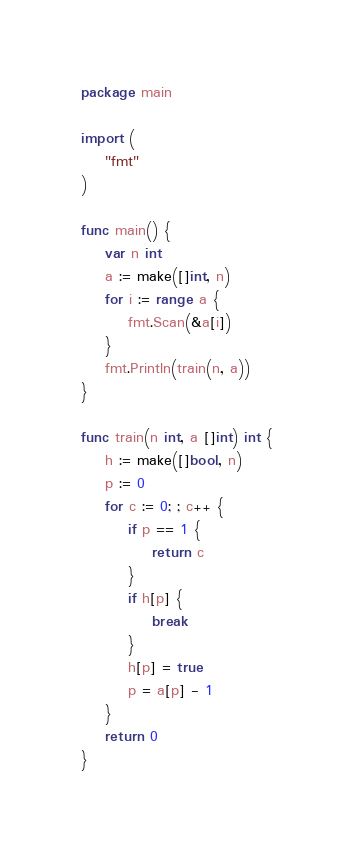Convert code to text. <code><loc_0><loc_0><loc_500><loc_500><_Go_>package main

import (
	"fmt"
)

func main() {
	var n int
	a := make([]int, n)
	for i := range a {
		fmt.Scan(&a[i])
	}
	fmt.Println(train(n, a))
}

func train(n int, a []int) int {
	h := make([]bool, n)
	p := 0
	for c := 0; ; c++ {
		if p == 1 {
			return c
		}
		if h[p] {
			break
		}
		h[p] = true
		p = a[p] - 1
	}
	return 0
}
</code> 